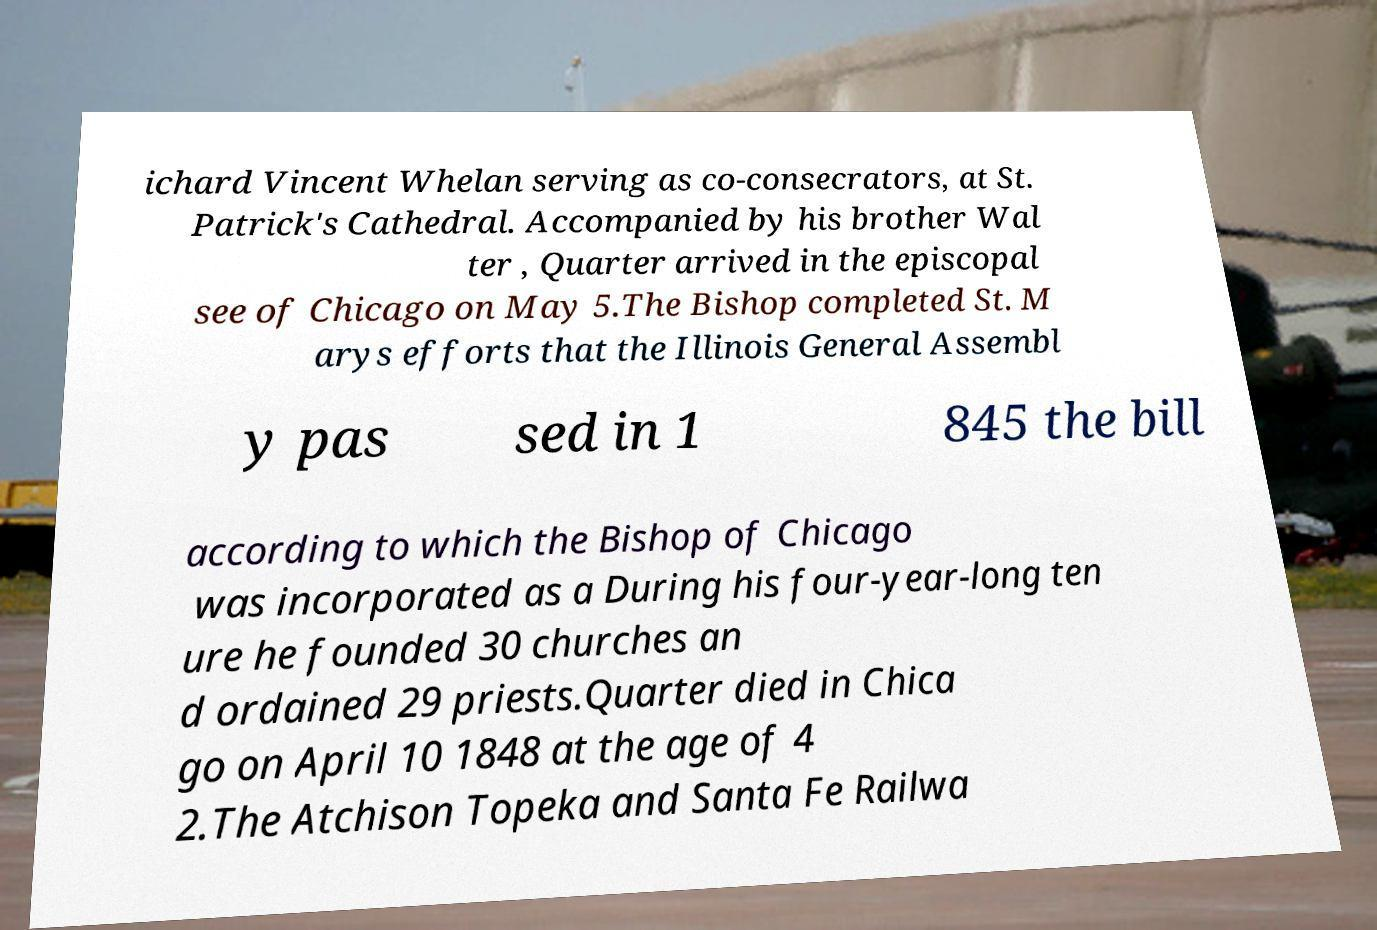Please read and relay the text visible in this image. What does it say? ichard Vincent Whelan serving as co-consecrators, at St. Patrick's Cathedral. Accompanied by his brother Wal ter , Quarter arrived in the episcopal see of Chicago on May 5.The Bishop completed St. M arys efforts that the Illinois General Assembl y pas sed in 1 845 the bill according to which the Bishop of Chicago was incorporated as a During his four-year-long ten ure he founded 30 churches an d ordained 29 priests.Quarter died in Chica go on April 10 1848 at the age of 4 2.The Atchison Topeka and Santa Fe Railwa 